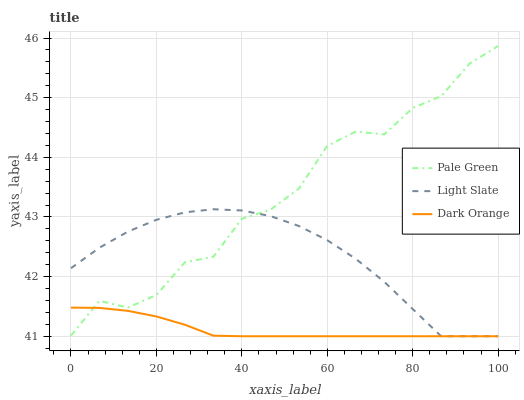Does Dark Orange have the minimum area under the curve?
Answer yes or no. Yes. Does Pale Green have the maximum area under the curve?
Answer yes or no. Yes. Does Pale Green have the minimum area under the curve?
Answer yes or no. No. Does Dark Orange have the maximum area under the curve?
Answer yes or no. No. Is Dark Orange the smoothest?
Answer yes or no. Yes. Is Pale Green the roughest?
Answer yes or no. Yes. Is Pale Green the smoothest?
Answer yes or no. No. Is Dark Orange the roughest?
Answer yes or no. No. Does Pale Green have the lowest value?
Answer yes or no. No. Does Dark Orange have the highest value?
Answer yes or no. No. 